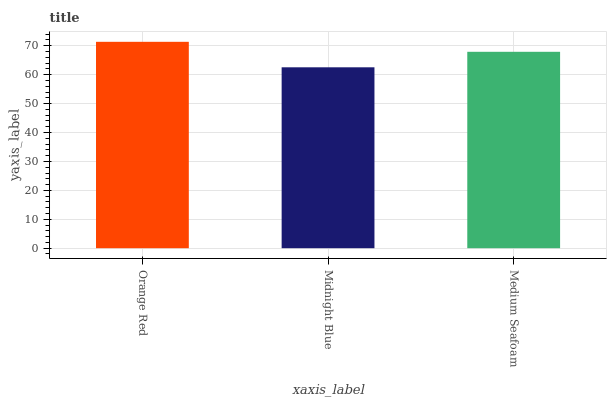Is Midnight Blue the minimum?
Answer yes or no. Yes. Is Orange Red the maximum?
Answer yes or no. Yes. Is Medium Seafoam the minimum?
Answer yes or no. No. Is Medium Seafoam the maximum?
Answer yes or no. No. Is Medium Seafoam greater than Midnight Blue?
Answer yes or no. Yes. Is Midnight Blue less than Medium Seafoam?
Answer yes or no. Yes. Is Midnight Blue greater than Medium Seafoam?
Answer yes or no. No. Is Medium Seafoam less than Midnight Blue?
Answer yes or no. No. Is Medium Seafoam the high median?
Answer yes or no. Yes. Is Medium Seafoam the low median?
Answer yes or no. Yes. Is Midnight Blue the high median?
Answer yes or no. No. Is Midnight Blue the low median?
Answer yes or no. No. 